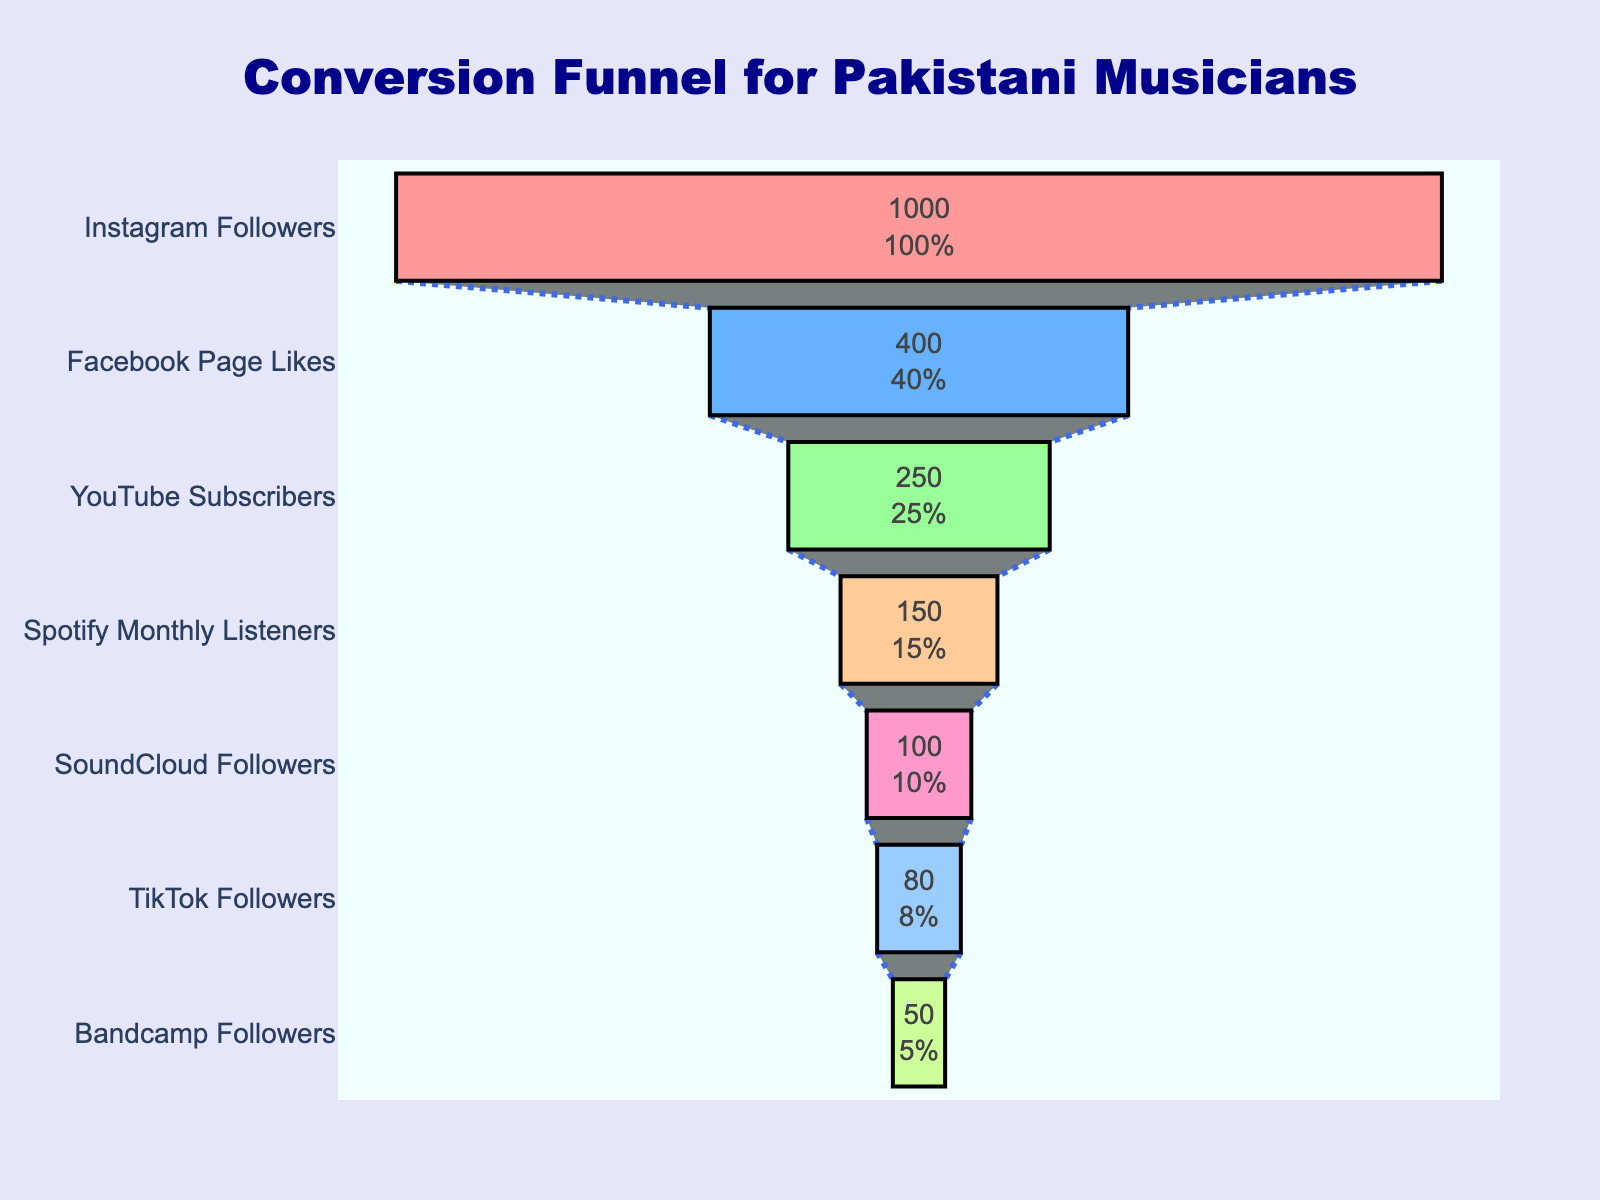How many stages are shown in the funnel chart? Count the number of distinct stages listed vertically on the chart.
Answer: 7 What is the title of the funnel chart? Look at the text displayed at the top center of the chart.
Answer: Conversion Funnel for Pakistani Musicians Which social media platform has the highest number of conversions? Identify the stage with the largest horizontal bar, signifying the most conversions.
Answer: Instagram Followers How many conversions does YouTube Subscribers have? Locate the bar associated with YouTube Subscribers and read the number inside it.
Answer: 250 What percentage of Instagram Followers converted to paying customers? Find Instagram Followers bar, then check the text showing the percentage value inside the bar.
Answer: 10% What is the difference in conversions between Facebook Page Likes and Spotify Monthly Listeners? Subtract the number of Spotify Monthly Listeners conversions from Facebook Page Likes conversions (400 - 150).
Answer: 250 Which stage has the lowest number of conversions? Identify the shortest bar on the chart, representing the stage with the fewest conversions.
Answer: Bandcamp Followers Are Facebook Page Likes conversions more than double the YouTube Subscribers conversions? Compare both conversions (400 and 250). Double of 250 would be 500, which is more than Facebook conversions.
Answer: No Name all the social media platforms with fewer than 200 conversions. Identify the stages with conversions below 200 by checking the value alongside each bar.
Answer: YouTube Subscribers, Spotify Monthly Listeners, SoundCloud Followers, TikTok Followers, Bandcamp Followers What is the total number of conversions from all stages combined? Sum the conversions from all stages: 1000 + 400 + 250 + 150 + 100 + 80 + 50.
Answer: 2030 